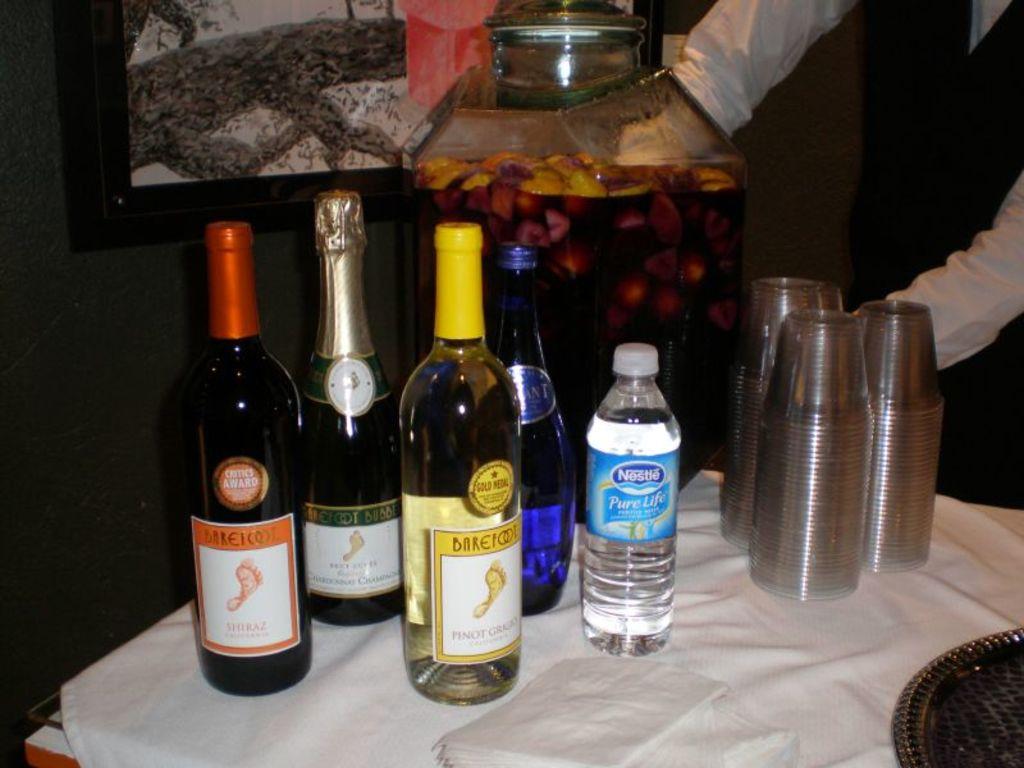What brand of wine is shown here?
Give a very brief answer. Barefoot. What type of water is it?
Your response must be concise. Nestle. 